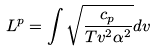<formula> <loc_0><loc_0><loc_500><loc_500>L ^ { p } = \int { \sqrt { \frac { c _ { p } } { T v ^ { 2 } \alpha ^ { 2 } } } d v }</formula> 